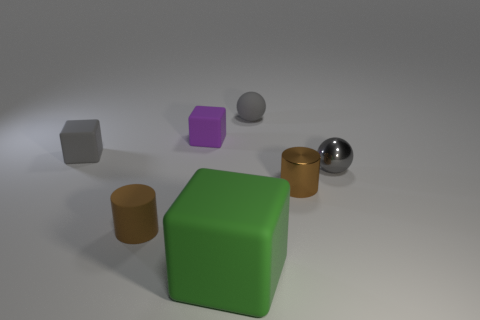Are there more brown shiny cylinders than tiny brown things?
Provide a short and direct response. No. Does the gray rubber object on the right side of the brown rubber object have the same size as the large rubber thing?
Provide a short and direct response. No. What number of tiny matte blocks have the same color as the metal ball?
Give a very brief answer. 1. Does the big rubber object have the same shape as the small purple matte thing?
Provide a succinct answer. Yes. Is there anything else that has the same size as the green cube?
Give a very brief answer. No. There is a green object that is the same shape as the purple object; what is its size?
Keep it short and to the point. Large. Are there more small rubber cubes that are to the right of the matte cylinder than small purple matte blocks that are in front of the large green block?
Ensure brevity in your answer.  Yes. Do the big block and the tiny object that is in front of the shiny cylinder have the same material?
Your answer should be compact. Yes. Is there any other thing that is the same shape as the brown shiny thing?
Provide a succinct answer. Yes. There is a object that is both in front of the tiny metallic cylinder and left of the big green rubber block; what color is it?
Provide a short and direct response. Brown. 